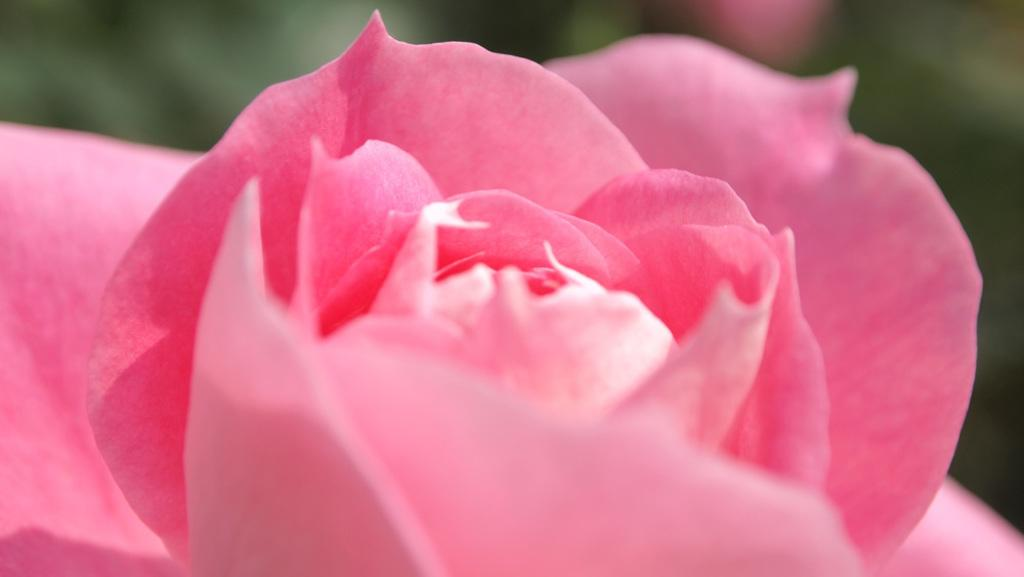What type of flower is in the image? There is a rose flower in the image. What color is the rose flower? The rose flower is pink in color. Can you describe the background of the image? The background of the image is blurred. What organization is responsible for the rose flower in the image? There is no indication in the image of any organization being responsible for the rose flower. What type of fruit is being crushed in the image? There is no fruit or any indication of crushing in the image. 